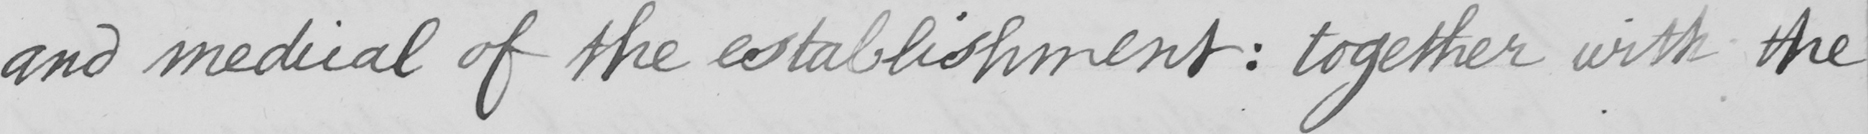Please provide the text content of this handwritten line. and medical of the establishment  :  together with the 